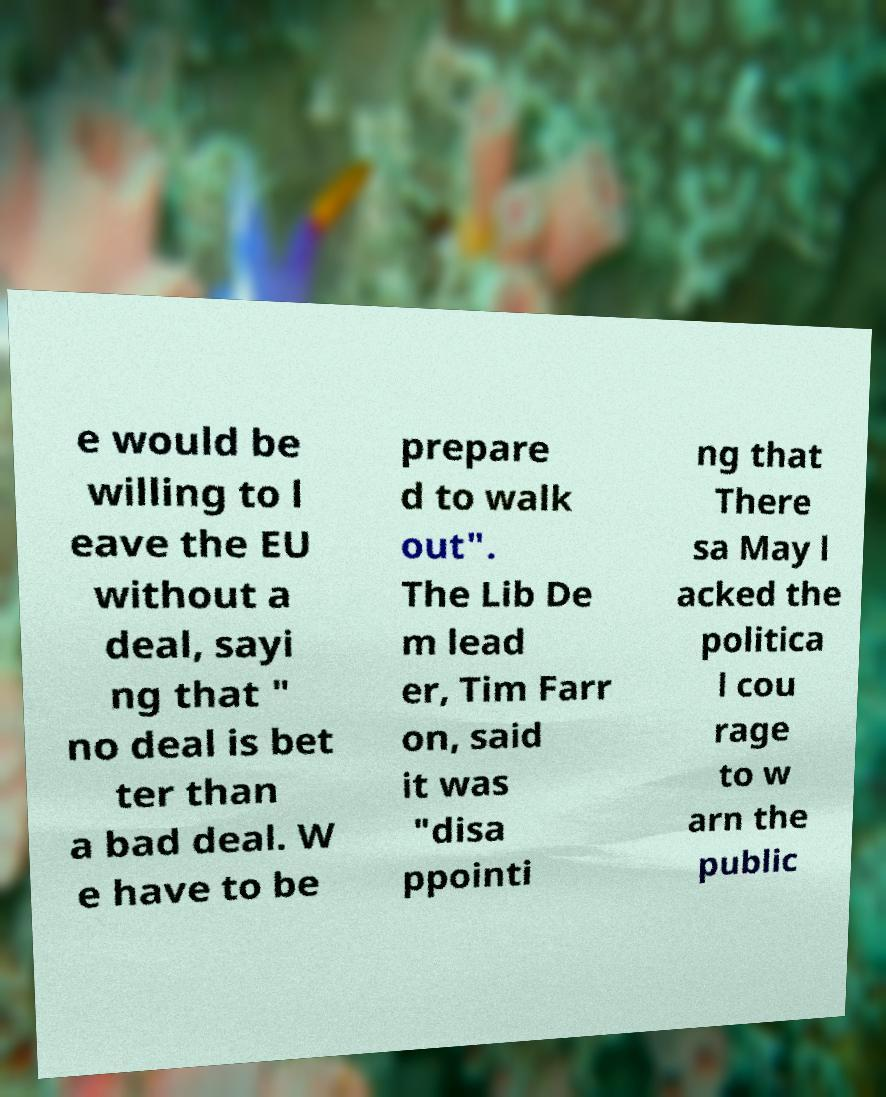Can you accurately transcribe the text from the provided image for me? e would be willing to l eave the EU without a deal, sayi ng that " no deal is bet ter than a bad deal. W e have to be prepare d to walk out". The Lib De m lead er, Tim Farr on, said it was "disa ppointi ng that There sa May l acked the politica l cou rage to w arn the public 